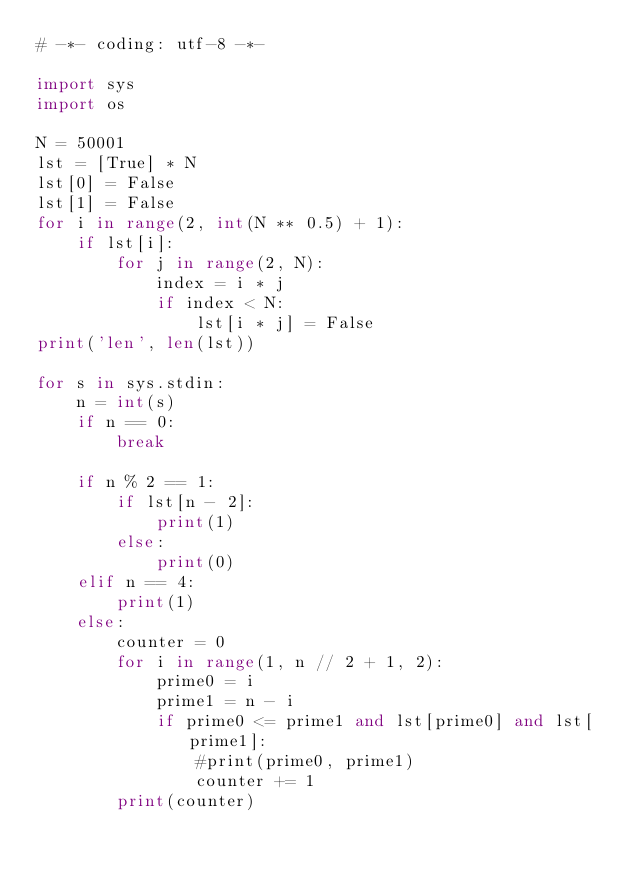Convert code to text. <code><loc_0><loc_0><loc_500><loc_500><_Python_># -*- coding: utf-8 -*-

import sys
import os

N = 50001
lst = [True] * N
lst[0] = False
lst[1] = False
for i in range(2, int(N ** 0.5) + 1):
    if lst[i]:
        for j in range(2, N):
            index = i * j
            if index < N:
                lst[i * j] = False
print('len', len(lst))

for s in sys.stdin:
    n = int(s)
    if n == 0:
        break

    if n % 2 == 1:
        if lst[n - 2]:
            print(1)
        else:
            print(0)
    elif n == 4:
        print(1)
    else:
        counter = 0
        for i in range(1, n // 2 + 1, 2):
            prime0 = i
            prime1 = n - i
            if prime0 <= prime1 and lst[prime0] and lst[prime1]:
                #print(prime0, prime1)
                counter += 1
        print(counter)</code> 